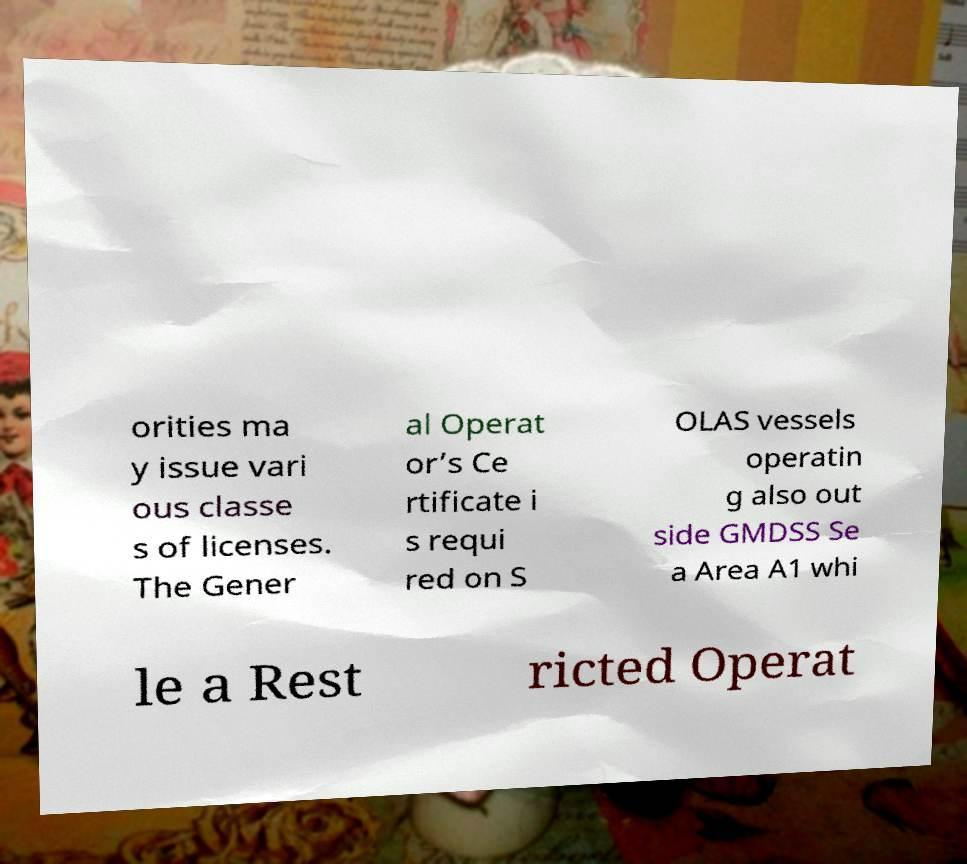There's text embedded in this image that I need extracted. Can you transcribe it verbatim? orities ma y issue vari ous classe s of licenses. The Gener al Operat or’s Ce rtificate i s requi red on S OLAS vessels operatin g also out side GMDSS Se a Area A1 whi le a Rest ricted Operat 